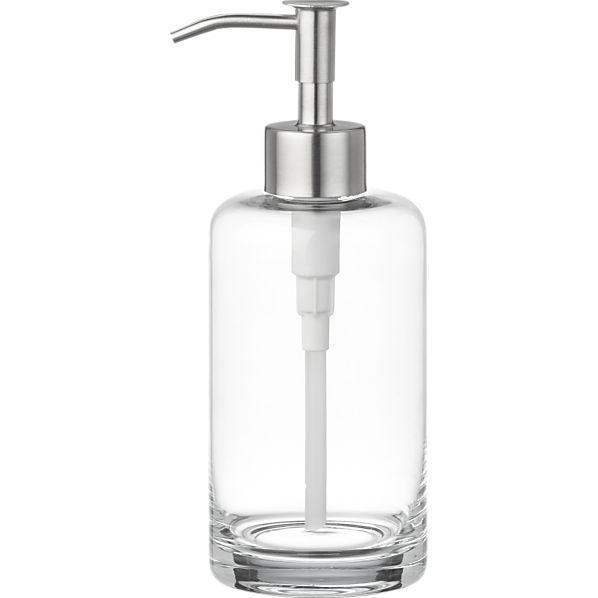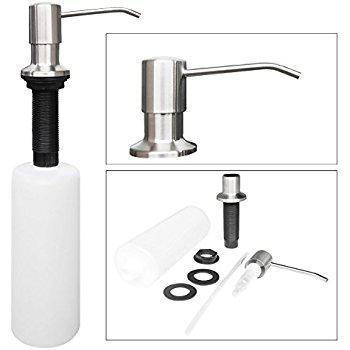The first image is the image on the left, the second image is the image on the right. Analyze the images presented: Is the assertion "The combined images show four complete pump-top dispensers, all of them transparent." valid? Answer yes or no. No. The first image is the image on the left, the second image is the image on the right. Evaluate the accuracy of this statement regarding the images: "The right image contains at least two dispensers.". Is it true? Answer yes or no. No. 